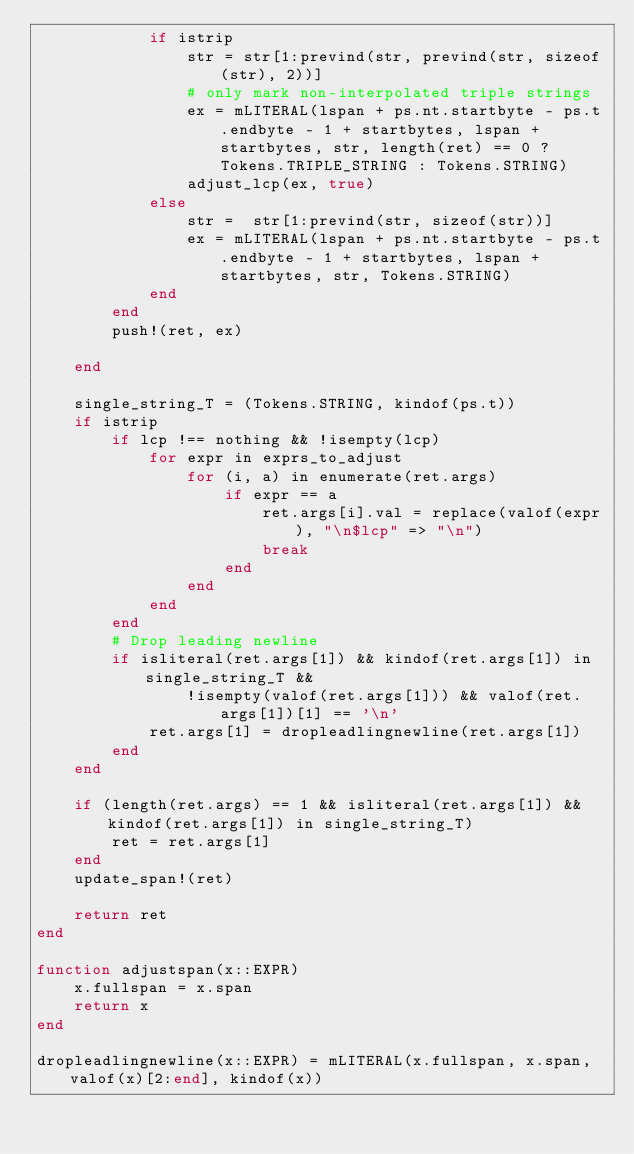<code> <loc_0><loc_0><loc_500><loc_500><_Julia_>            if istrip
                str = str[1:prevind(str, prevind(str, sizeof(str), 2))]
                # only mark non-interpolated triple strings
                ex = mLITERAL(lspan + ps.nt.startbyte - ps.t.endbyte - 1 + startbytes, lspan + startbytes, str, length(ret) == 0 ? Tokens.TRIPLE_STRING : Tokens.STRING)
                adjust_lcp(ex, true)
            else
                str =  str[1:prevind(str, sizeof(str))]
                ex = mLITERAL(lspan + ps.nt.startbyte - ps.t.endbyte - 1 + startbytes, lspan + startbytes, str, Tokens.STRING)
            end
        end
        push!(ret, ex)

    end

    single_string_T = (Tokens.STRING, kindof(ps.t))
    if istrip
        if lcp !== nothing && !isempty(lcp)
            for expr in exprs_to_adjust
                for (i, a) in enumerate(ret.args)
                    if expr == a
                        ret.args[i].val = replace(valof(expr), "\n$lcp" => "\n")
                        break
                    end
                end
            end
        end
        # Drop leading newline
        if isliteral(ret.args[1]) && kindof(ret.args[1]) in single_string_T &&
                !isempty(valof(ret.args[1])) && valof(ret.args[1])[1] == '\n'
            ret.args[1] = dropleadlingnewline(ret.args[1])
        end
    end

    if (length(ret.args) == 1 && isliteral(ret.args[1]) && kindof(ret.args[1]) in single_string_T)
        ret = ret.args[1]
    end
    update_span!(ret)

    return ret
end

function adjustspan(x::EXPR)
    x.fullspan = x.span
    return x
end

dropleadlingnewline(x::EXPR) = mLITERAL(x.fullspan, x.span, valof(x)[2:end], kindof(x))
</code> 